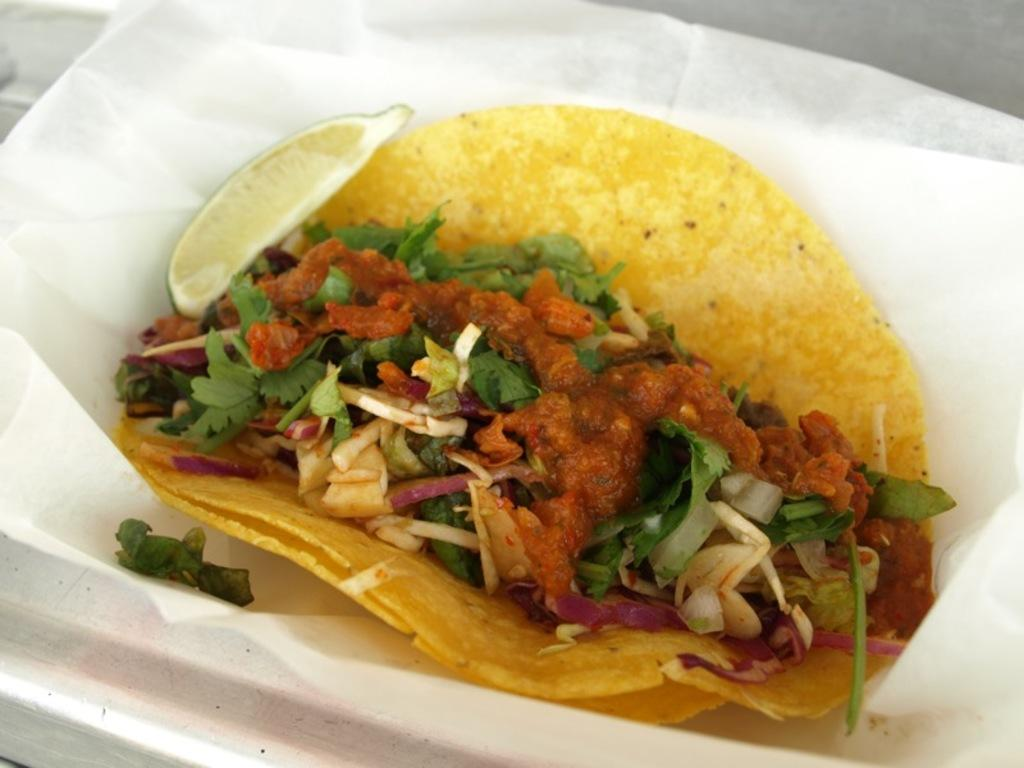What type of food can be seen in the image? There is food in the image, but the specific type cannot be determined from the facts provided. What colors are present in the food? The food has colors including brown, yellow, green, and white. How is the food arranged in the image? The food is in a plate. What color is the plate? The plate is white. Are there any plants growing in the food in the image? There is no information about plants in the image, and the food is in a plate, so it is unlikely that plants are growing in it. 